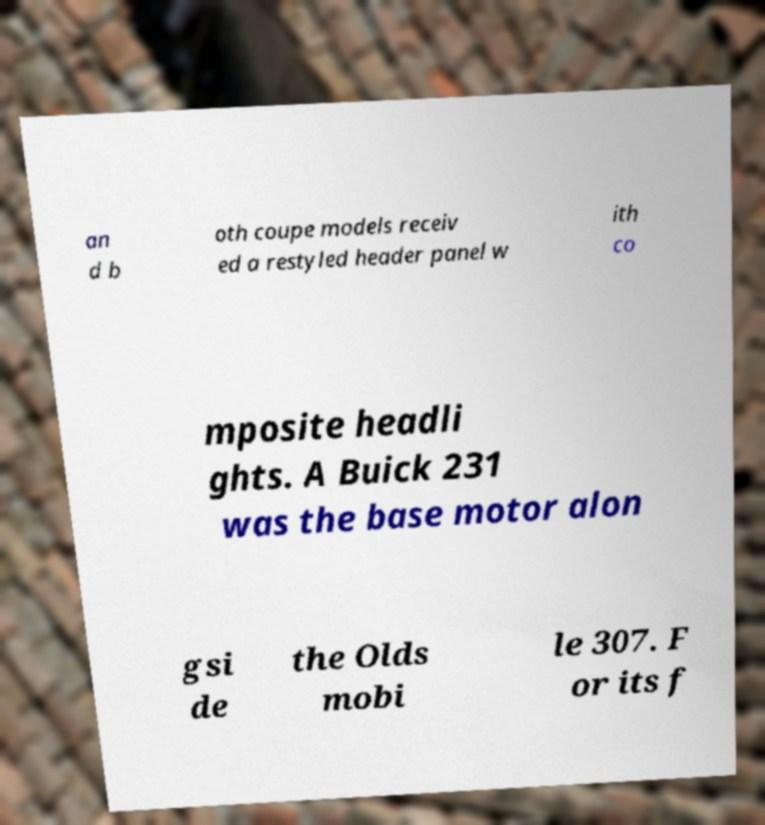What messages or text are displayed in this image? I need them in a readable, typed format. an d b oth coupe models receiv ed a restyled header panel w ith co mposite headli ghts. A Buick 231 was the base motor alon gsi de the Olds mobi le 307. F or its f 